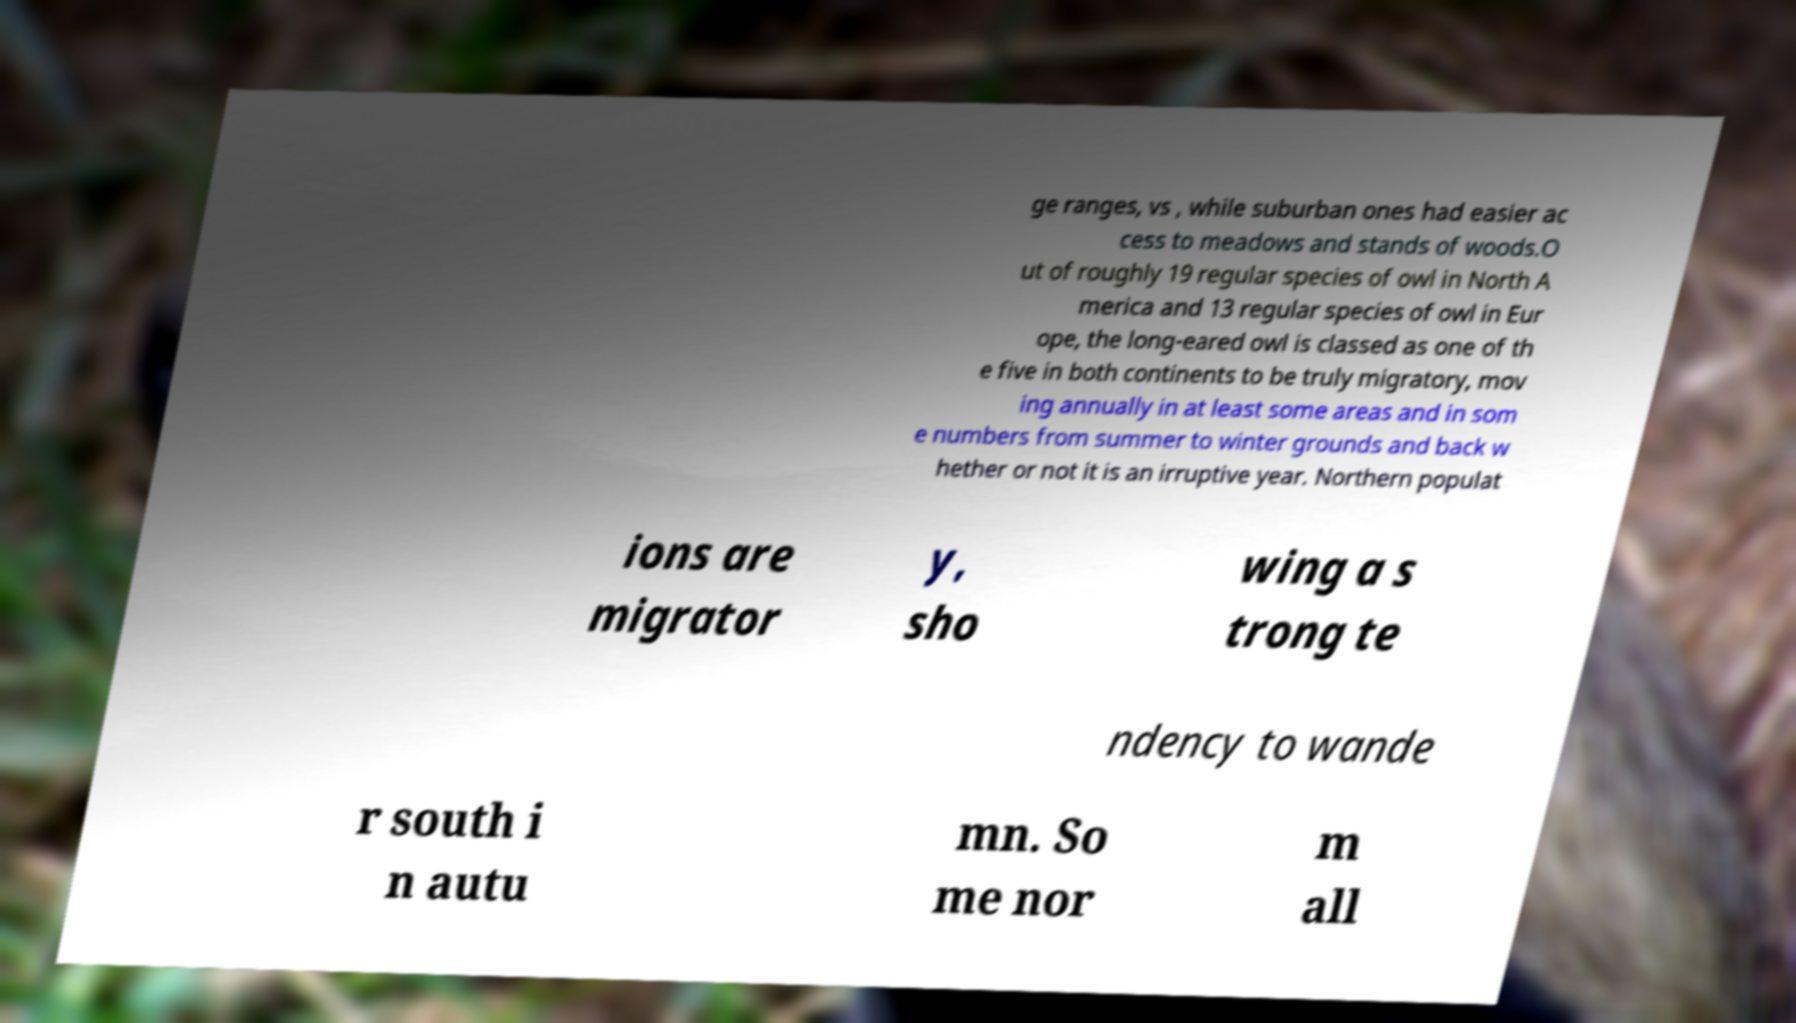Can you read and provide the text displayed in the image?This photo seems to have some interesting text. Can you extract and type it out for me? ge ranges, vs , while suburban ones had easier ac cess to meadows and stands of woods.O ut of roughly 19 regular species of owl in North A merica and 13 regular species of owl in Eur ope, the long-eared owl is classed as one of th e five in both continents to be truly migratory, mov ing annually in at least some areas and in som e numbers from summer to winter grounds and back w hether or not it is an irruptive year. Northern populat ions are migrator y, sho wing a s trong te ndency to wande r south i n autu mn. So me nor m all 